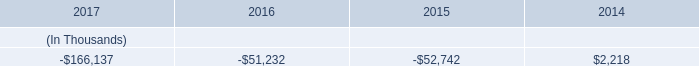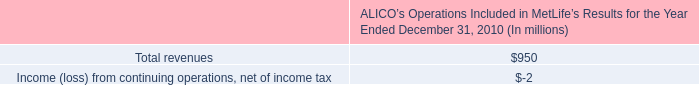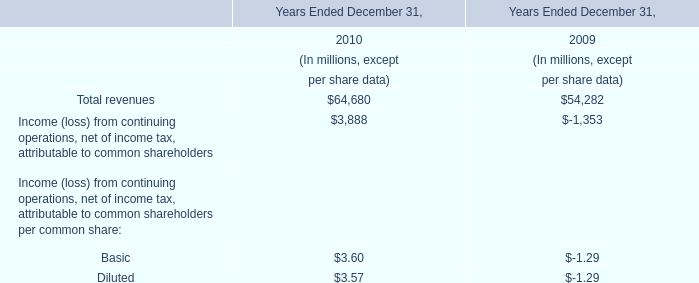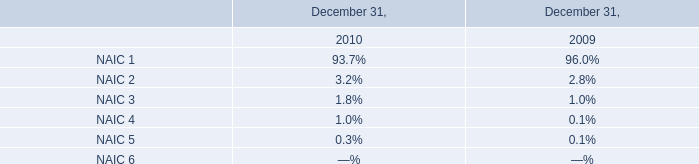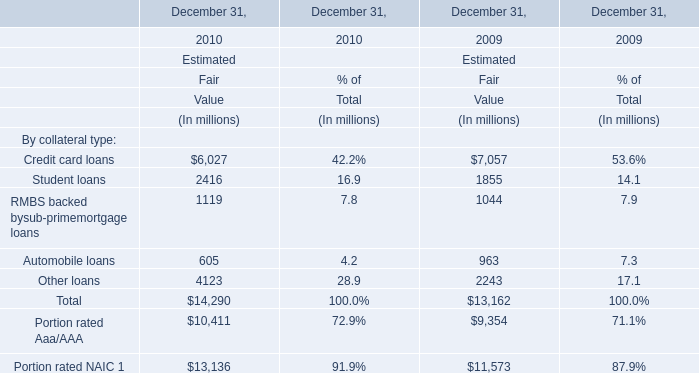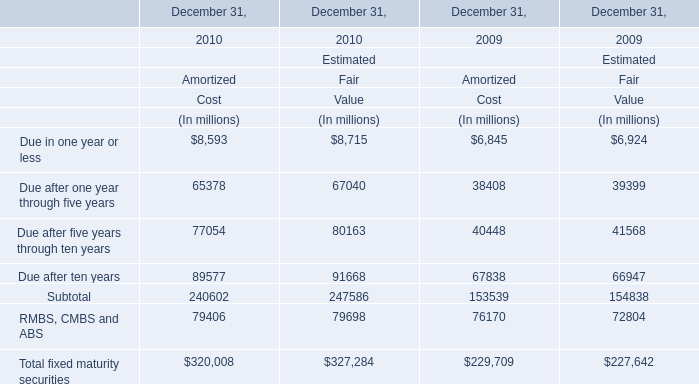What will RMBS, CMBS and ABS for Amortized be like in 2011 if it develops with the same increasing rate as current? (in million) 
Computations: (79406 * (1 + ((79406 - 76170) / 76170)))
Answer: 82779.47796. 